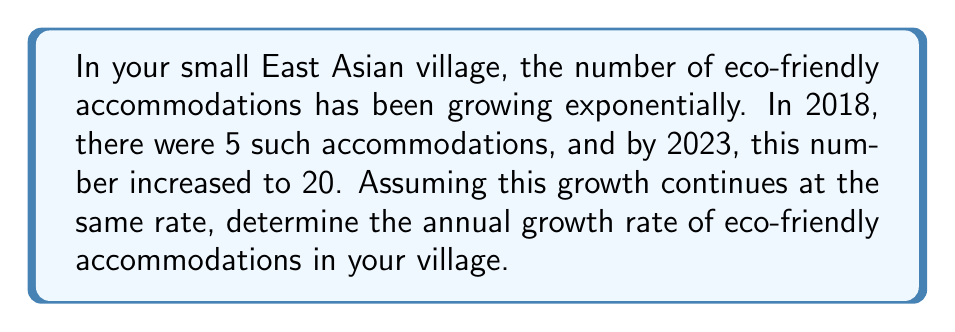Give your solution to this math problem. Let's solve this step-by-step using the exponential growth formula:

1) The exponential growth formula is:
   $A = P(1 + r)^t$
   where A is the final amount, P is the initial amount, r is the annual growth rate, and t is the time in years.

2) We know:
   P = 5 (initial number of accommodations in 2018)
   A = 20 (final number of accommodations in 2023)
   t = 5 years (from 2018 to 2023)

3) Let's plug these values into the formula:
   $20 = 5(1 + r)^5$

4) Divide both sides by 5:
   $4 = (1 + r)^5$

5) Take the 5th root of both sides:
   $\sqrt[5]{4} = 1 + r$

6) Subtract 1 from both sides:
   $\sqrt[5]{4} - 1 = r$

7) Calculate the value:
   $r = \sqrt[5]{4} - 1 \approx 1.3195 - 1 = 0.3195$

8) Convert to a percentage:
   $0.3195 \times 100\% = 31.95\%$

Therefore, the annual growth rate is approximately 31.95%.
Answer: 31.95% 